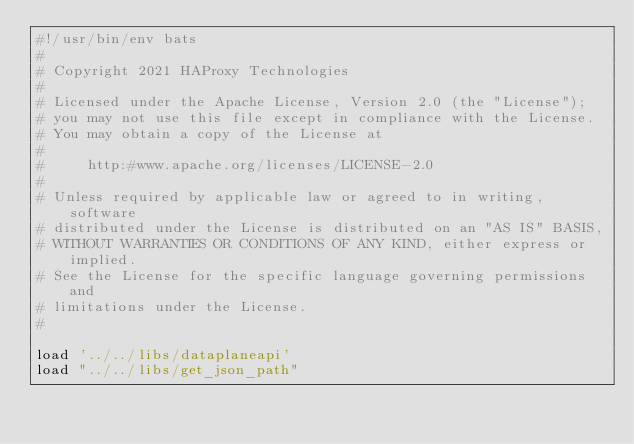Convert code to text. <code><loc_0><loc_0><loc_500><loc_500><_Bash_>#!/usr/bin/env bats
#
# Copyright 2021 HAProxy Technologies
#
# Licensed under the Apache License, Version 2.0 (the "License");
# you may not use this file except in compliance with the License.
# You may obtain a copy of the License at
#
#     http:#www.apache.org/licenses/LICENSE-2.0
#
# Unless required by applicable law or agreed to in writing, software
# distributed under the License is distributed on an "AS IS" BASIS,
# WITHOUT WARRANTIES OR CONDITIONS OF ANY KIND, either express or implied.
# See the License for the specific language governing permissions and
# limitations under the License.
#

load '../../libs/dataplaneapi'
load "../../libs/get_json_path"</code> 